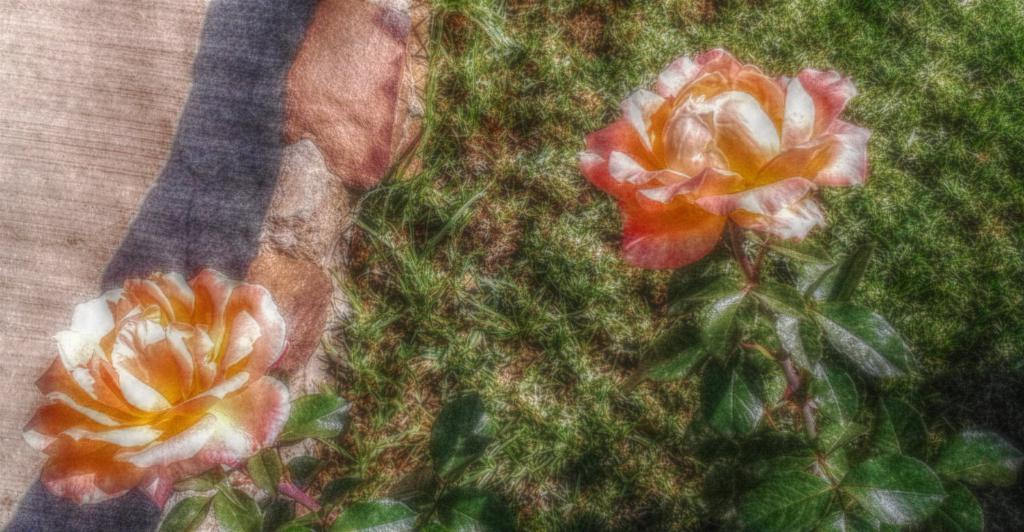How many flowers are on the plant in the image? There are two flowers on a plant in the image. What type of vegetation is on the ground in the image? There is grass on the ground in the image. What feature is present for walking in the image? There is a path in the image. What type of rail can be seen in the image? There is no rail present in the image. What emotion is being expressed by the flowers in the image? The flowers in the image are not expressing any emotions, as they are inanimate objects. 